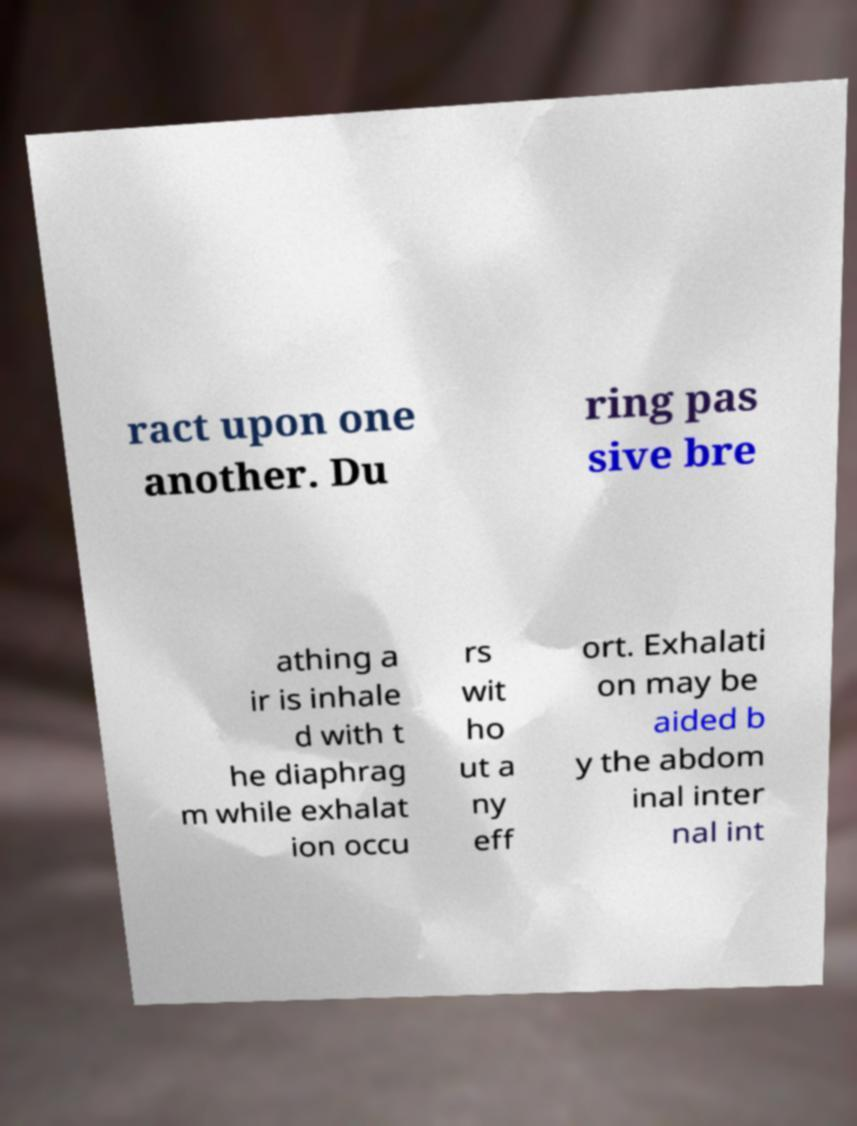Please read and relay the text visible in this image. What does it say? ract upon one another. Du ring pas sive bre athing a ir is inhale d with t he diaphrag m while exhalat ion occu rs wit ho ut a ny eff ort. Exhalati on may be aided b y the abdom inal inter nal int 